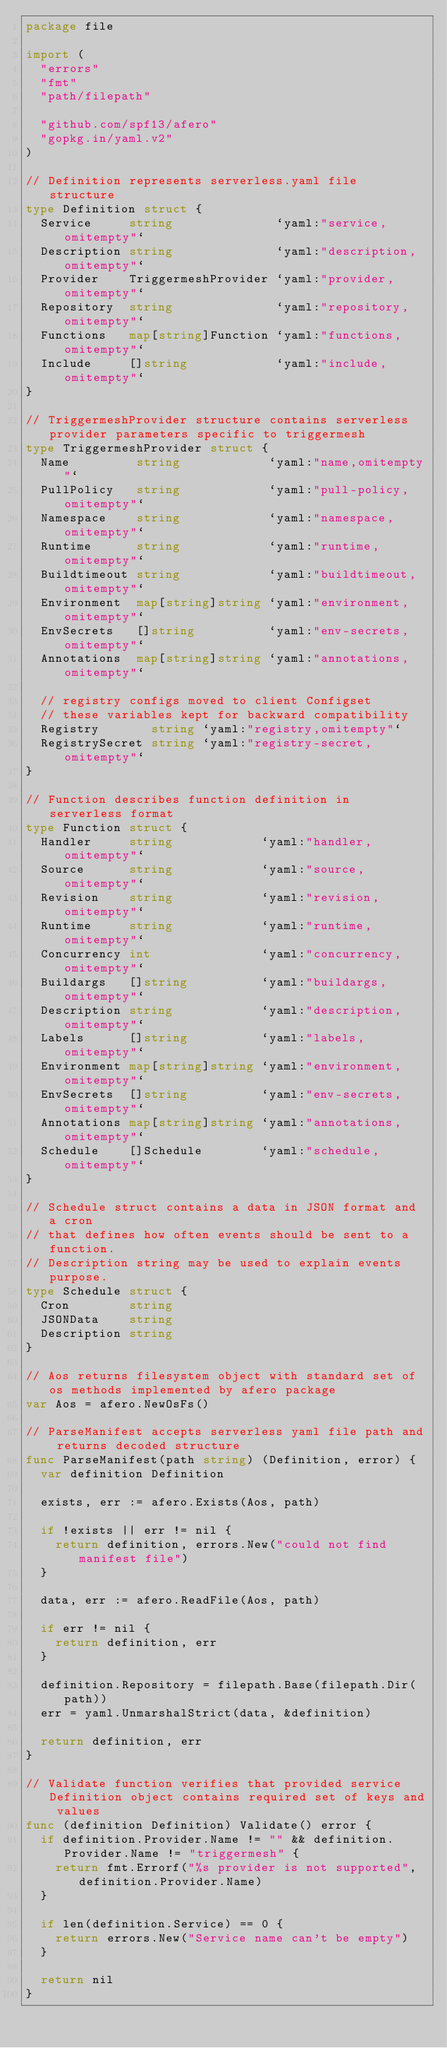Convert code to text. <code><loc_0><loc_0><loc_500><loc_500><_Go_>package file

import (
	"errors"
	"fmt"
	"path/filepath"

	"github.com/spf13/afero"
	"gopkg.in/yaml.v2"
)

// Definition represents serverless.yaml file structure
type Definition struct {
	Service     string              `yaml:"service,omitempty"`
	Description string              `yaml:"description,omitempty"`
	Provider    TriggermeshProvider `yaml:"provider,omitempty"`
	Repository  string              `yaml:"repository,omitempty"`
	Functions   map[string]Function `yaml:"functions,omitempty"`
	Include     []string            `yaml:"include,omitempty"`
}

// TriggermeshProvider structure contains serverless provider parameters specific to triggermesh
type TriggermeshProvider struct {
	Name         string            `yaml:"name,omitempty"`
	PullPolicy   string            `yaml:"pull-policy,omitempty"`
	Namespace    string            `yaml:"namespace,omitempty"`
	Runtime      string            `yaml:"runtime,omitempty"`
	Buildtimeout string            `yaml:"buildtimeout,omitempty"`
	Environment  map[string]string `yaml:"environment,omitempty"`
	EnvSecrets   []string          `yaml:"env-secrets,omitempty"`
	Annotations  map[string]string `yaml:"annotations,omitempty"`

	// registry configs moved to client Configset
	// these variables kept for backward compatibility
	Registry       string `yaml:"registry,omitempty"`
	RegistrySecret string `yaml:"registry-secret,omitempty"`
}

// Function describes function definition in serverless format
type Function struct {
	Handler     string            `yaml:"handler,omitempty"`
	Source      string            `yaml:"source,omitempty"`
	Revision    string            `yaml:"revision,omitempty"`
	Runtime     string            `yaml:"runtime,omitempty"`
	Concurrency int               `yaml:"concurrency,omitempty"`
	Buildargs   []string          `yaml:"buildargs,omitempty"`
	Description string            `yaml:"description,omitempty"`
	Labels      []string          `yaml:"labels,omitempty"`
	Environment map[string]string `yaml:"environment,omitempty"`
	EnvSecrets  []string          `yaml:"env-secrets,omitempty"`
	Annotations map[string]string `yaml:"annotations,omitempty"`
	Schedule    []Schedule        `yaml:"schedule,omitempty"`
}

// Schedule struct contains a data in JSON format and a cron
// that defines how often events should be sent to a function.
// Description string may be used to explain events purpose.
type Schedule struct {
	Cron        string
	JSONData    string
	Description string
}

// Aos returns filesystem object with standard set of os methods implemented by afero package
var Aos = afero.NewOsFs()

// ParseManifest accepts serverless yaml file path and returns decoded structure
func ParseManifest(path string) (Definition, error) {
	var definition Definition

	exists, err := afero.Exists(Aos, path)

	if !exists || err != nil {
		return definition, errors.New("could not find manifest file")
	}

	data, err := afero.ReadFile(Aos, path)

	if err != nil {
		return definition, err
	}

	definition.Repository = filepath.Base(filepath.Dir(path))
	err = yaml.UnmarshalStrict(data, &definition)

	return definition, err
}

// Validate function verifies that provided service Definition object contains required set of keys and values
func (definition Definition) Validate() error {
	if definition.Provider.Name != "" && definition.Provider.Name != "triggermesh" {
		return fmt.Errorf("%s provider is not supported", definition.Provider.Name)
	}

	if len(definition.Service) == 0 {
		return errors.New("Service name can't be empty")
	}

	return nil
}
</code> 